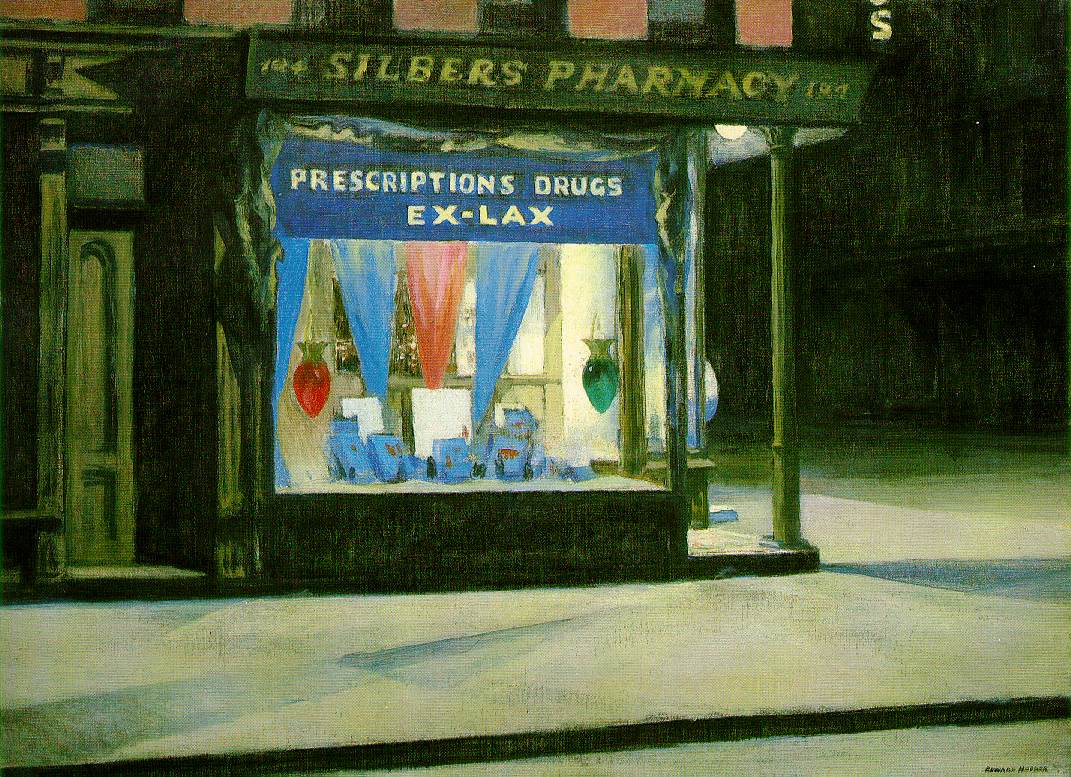Describe the following image.
 The image depicts a scene of an urban nightscape, specifically focusing on the storefront of a pharmacy named "Silber's Pharmacy". The painting is executed in the style of American realism, a genre known for its detailed and unembellished depiction of everyday life. 

The color palette is predominantly dark and muted, creating a somber and quiet atmosphere that is characteristic of a city street at night. However, the window display of the pharmacy provides a stark contrast with its bright blue and red hues. 

The sign above the window reads "Prescriptions Drugs Ex-Lax", indicating the nature of the business. The window display itself is filled with various bottles and boxes of medicine, further emphasizing the function of the building. Despite the vibrancy of the window display, the street itself is devoid of people, adding to the overall quiet and somber mood of the painting. 

The painting captures a common urban scene, yet the attention to detail and the interplay of light and shadow create a sense of intrigue and depth. It's a snapshot of everyday life, yet it also invites the viewer to imagine the stories that might unfold in this setting. 